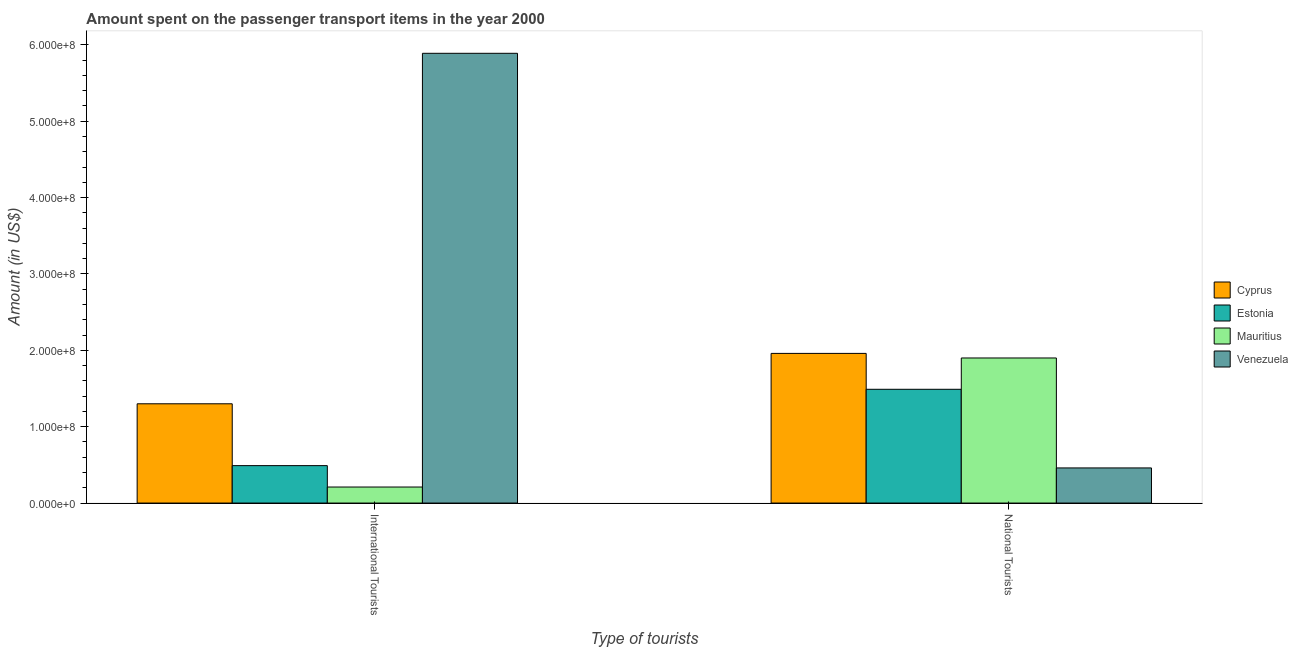How many different coloured bars are there?
Make the answer very short. 4. Are the number of bars per tick equal to the number of legend labels?
Give a very brief answer. Yes. Are the number of bars on each tick of the X-axis equal?
Provide a short and direct response. Yes. How many bars are there on the 1st tick from the left?
Ensure brevity in your answer.  4. What is the label of the 2nd group of bars from the left?
Your response must be concise. National Tourists. What is the amount spent on transport items of international tourists in Venezuela?
Your answer should be compact. 5.89e+08. Across all countries, what is the maximum amount spent on transport items of international tourists?
Your response must be concise. 5.89e+08. Across all countries, what is the minimum amount spent on transport items of national tourists?
Your answer should be very brief. 4.60e+07. In which country was the amount spent on transport items of national tourists maximum?
Your response must be concise. Cyprus. In which country was the amount spent on transport items of international tourists minimum?
Provide a short and direct response. Mauritius. What is the total amount spent on transport items of international tourists in the graph?
Offer a terse response. 7.89e+08. What is the difference between the amount spent on transport items of national tourists in Estonia and that in Mauritius?
Offer a terse response. -4.10e+07. What is the difference between the amount spent on transport items of international tourists in Estonia and the amount spent on transport items of national tourists in Mauritius?
Ensure brevity in your answer.  -1.41e+08. What is the average amount spent on transport items of international tourists per country?
Offer a terse response. 1.97e+08. What is the difference between the amount spent on transport items of international tourists and amount spent on transport items of national tourists in Cyprus?
Provide a succinct answer. -6.60e+07. In how many countries, is the amount spent on transport items of national tourists greater than 560000000 US$?
Your answer should be very brief. 0. What is the ratio of the amount spent on transport items of national tourists in Venezuela to that in Cyprus?
Your answer should be compact. 0.23. Is the amount spent on transport items of national tourists in Venezuela less than that in Cyprus?
Ensure brevity in your answer.  Yes. In how many countries, is the amount spent on transport items of national tourists greater than the average amount spent on transport items of national tourists taken over all countries?
Your answer should be very brief. 3. What does the 4th bar from the left in National Tourists represents?
Keep it short and to the point. Venezuela. What does the 2nd bar from the right in International Tourists represents?
Make the answer very short. Mauritius. How many bars are there?
Keep it short and to the point. 8. Are the values on the major ticks of Y-axis written in scientific E-notation?
Give a very brief answer. Yes. Does the graph contain any zero values?
Your answer should be compact. No. How many legend labels are there?
Ensure brevity in your answer.  4. How are the legend labels stacked?
Your answer should be very brief. Vertical. What is the title of the graph?
Make the answer very short. Amount spent on the passenger transport items in the year 2000. What is the label or title of the X-axis?
Ensure brevity in your answer.  Type of tourists. What is the label or title of the Y-axis?
Give a very brief answer. Amount (in US$). What is the Amount (in US$) in Cyprus in International Tourists?
Your answer should be very brief. 1.30e+08. What is the Amount (in US$) of Estonia in International Tourists?
Offer a terse response. 4.90e+07. What is the Amount (in US$) in Mauritius in International Tourists?
Your response must be concise. 2.10e+07. What is the Amount (in US$) of Venezuela in International Tourists?
Your answer should be very brief. 5.89e+08. What is the Amount (in US$) in Cyprus in National Tourists?
Keep it short and to the point. 1.96e+08. What is the Amount (in US$) in Estonia in National Tourists?
Provide a short and direct response. 1.49e+08. What is the Amount (in US$) of Mauritius in National Tourists?
Provide a succinct answer. 1.90e+08. What is the Amount (in US$) of Venezuela in National Tourists?
Offer a terse response. 4.60e+07. Across all Type of tourists, what is the maximum Amount (in US$) of Cyprus?
Provide a short and direct response. 1.96e+08. Across all Type of tourists, what is the maximum Amount (in US$) in Estonia?
Your response must be concise. 1.49e+08. Across all Type of tourists, what is the maximum Amount (in US$) of Mauritius?
Ensure brevity in your answer.  1.90e+08. Across all Type of tourists, what is the maximum Amount (in US$) in Venezuela?
Your response must be concise. 5.89e+08. Across all Type of tourists, what is the minimum Amount (in US$) of Cyprus?
Provide a succinct answer. 1.30e+08. Across all Type of tourists, what is the minimum Amount (in US$) in Estonia?
Provide a succinct answer. 4.90e+07. Across all Type of tourists, what is the minimum Amount (in US$) of Mauritius?
Offer a terse response. 2.10e+07. Across all Type of tourists, what is the minimum Amount (in US$) of Venezuela?
Your answer should be very brief. 4.60e+07. What is the total Amount (in US$) of Cyprus in the graph?
Ensure brevity in your answer.  3.26e+08. What is the total Amount (in US$) of Estonia in the graph?
Your answer should be very brief. 1.98e+08. What is the total Amount (in US$) of Mauritius in the graph?
Your response must be concise. 2.11e+08. What is the total Amount (in US$) in Venezuela in the graph?
Keep it short and to the point. 6.35e+08. What is the difference between the Amount (in US$) of Cyprus in International Tourists and that in National Tourists?
Your answer should be very brief. -6.60e+07. What is the difference between the Amount (in US$) in Estonia in International Tourists and that in National Tourists?
Your response must be concise. -1.00e+08. What is the difference between the Amount (in US$) of Mauritius in International Tourists and that in National Tourists?
Ensure brevity in your answer.  -1.69e+08. What is the difference between the Amount (in US$) in Venezuela in International Tourists and that in National Tourists?
Make the answer very short. 5.43e+08. What is the difference between the Amount (in US$) of Cyprus in International Tourists and the Amount (in US$) of Estonia in National Tourists?
Provide a succinct answer. -1.90e+07. What is the difference between the Amount (in US$) of Cyprus in International Tourists and the Amount (in US$) of Mauritius in National Tourists?
Ensure brevity in your answer.  -6.00e+07. What is the difference between the Amount (in US$) of Cyprus in International Tourists and the Amount (in US$) of Venezuela in National Tourists?
Make the answer very short. 8.40e+07. What is the difference between the Amount (in US$) in Estonia in International Tourists and the Amount (in US$) in Mauritius in National Tourists?
Your response must be concise. -1.41e+08. What is the difference between the Amount (in US$) of Estonia in International Tourists and the Amount (in US$) of Venezuela in National Tourists?
Offer a very short reply. 3.00e+06. What is the difference between the Amount (in US$) of Mauritius in International Tourists and the Amount (in US$) of Venezuela in National Tourists?
Ensure brevity in your answer.  -2.50e+07. What is the average Amount (in US$) of Cyprus per Type of tourists?
Make the answer very short. 1.63e+08. What is the average Amount (in US$) of Estonia per Type of tourists?
Keep it short and to the point. 9.90e+07. What is the average Amount (in US$) of Mauritius per Type of tourists?
Make the answer very short. 1.06e+08. What is the average Amount (in US$) of Venezuela per Type of tourists?
Offer a very short reply. 3.18e+08. What is the difference between the Amount (in US$) in Cyprus and Amount (in US$) in Estonia in International Tourists?
Your answer should be very brief. 8.10e+07. What is the difference between the Amount (in US$) of Cyprus and Amount (in US$) of Mauritius in International Tourists?
Give a very brief answer. 1.09e+08. What is the difference between the Amount (in US$) of Cyprus and Amount (in US$) of Venezuela in International Tourists?
Your response must be concise. -4.59e+08. What is the difference between the Amount (in US$) of Estonia and Amount (in US$) of Mauritius in International Tourists?
Keep it short and to the point. 2.80e+07. What is the difference between the Amount (in US$) in Estonia and Amount (in US$) in Venezuela in International Tourists?
Your answer should be very brief. -5.40e+08. What is the difference between the Amount (in US$) of Mauritius and Amount (in US$) of Venezuela in International Tourists?
Provide a short and direct response. -5.68e+08. What is the difference between the Amount (in US$) in Cyprus and Amount (in US$) in Estonia in National Tourists?
Your response must be concise. 4.70e+07. What is the difference between the Amount (in US$) in Cyprus and Amount (in US$) in Mauritius in National Tourists?
Your response must be concise. 6.00e+06. What is the difference between the Amount (in US$) in Cyprus and Amount (in US$) in Venezuela in National Tourists?
Provide a short and direct response. 1.50e+08. What is the difference between the Amount (in US$) in Estonia and Amount (in US$) in Mauritius in National Tourists?
Give a very brief answer. -4.10e+07. What is the difference between the Amount (in US$) in Estonia and Amount (in US$) in Venezuela in National Tourists?
Keep it short and to the point. 1.03e+08. What is the difference between the Amount (in US$) in Mauritius and Amount (in US$) in Venezuela in National Tourists?
Keep it short and to the point. 1.44e+08. What is the ratio of the Amount (in US$) in Cyprus in International Tourists to that in National Tourists?
Provide a short and direct response. 0.66. What is the ratio of the Amount (in US$) of Estonia in International Tourists to that in National Tourists?
Make the answer very short. 0.33. What is the ratio of the Amount (in US$) in Mauritius in International Tourists to that in National Tourists?
Ensure brevity in your answer.  0.11. What is the ratio of the Amount (in US$) of Venezuela in International Tourists to that in National Tourists?
Provide a short and direct response. 12.8. What is the difference between the highest and the second highest Amount (in US$) in Cyprus?
Ensure brevity in your answer.  6.60e+07. What is the difference between the highest and the second highest Amount (in US$) in Mauritius?
Give a very brief answer. 1.69e+08. What is the difference between the highest and the second highest Amount (in US$) of Venezuela?
Your response must be concise. 5.43e+08. What is the difference between the highest and the lowest Amount (in US$) in Cyprus?
Make the answer very short. 6.60e+07. What is the difference between the highest and the lowest Amount (in US$) of Estonia?
Provide a short and direct response. 1.00e+08. What is the difference between the highest and the lowest Amount (in US$) of Mauritius?
Provide a succinct answer. 1.69e+08. What is the difference between the highest and the lowest Amount (in US$) of Venezuela?
Keep it short and to the point. 5.43e+08. 